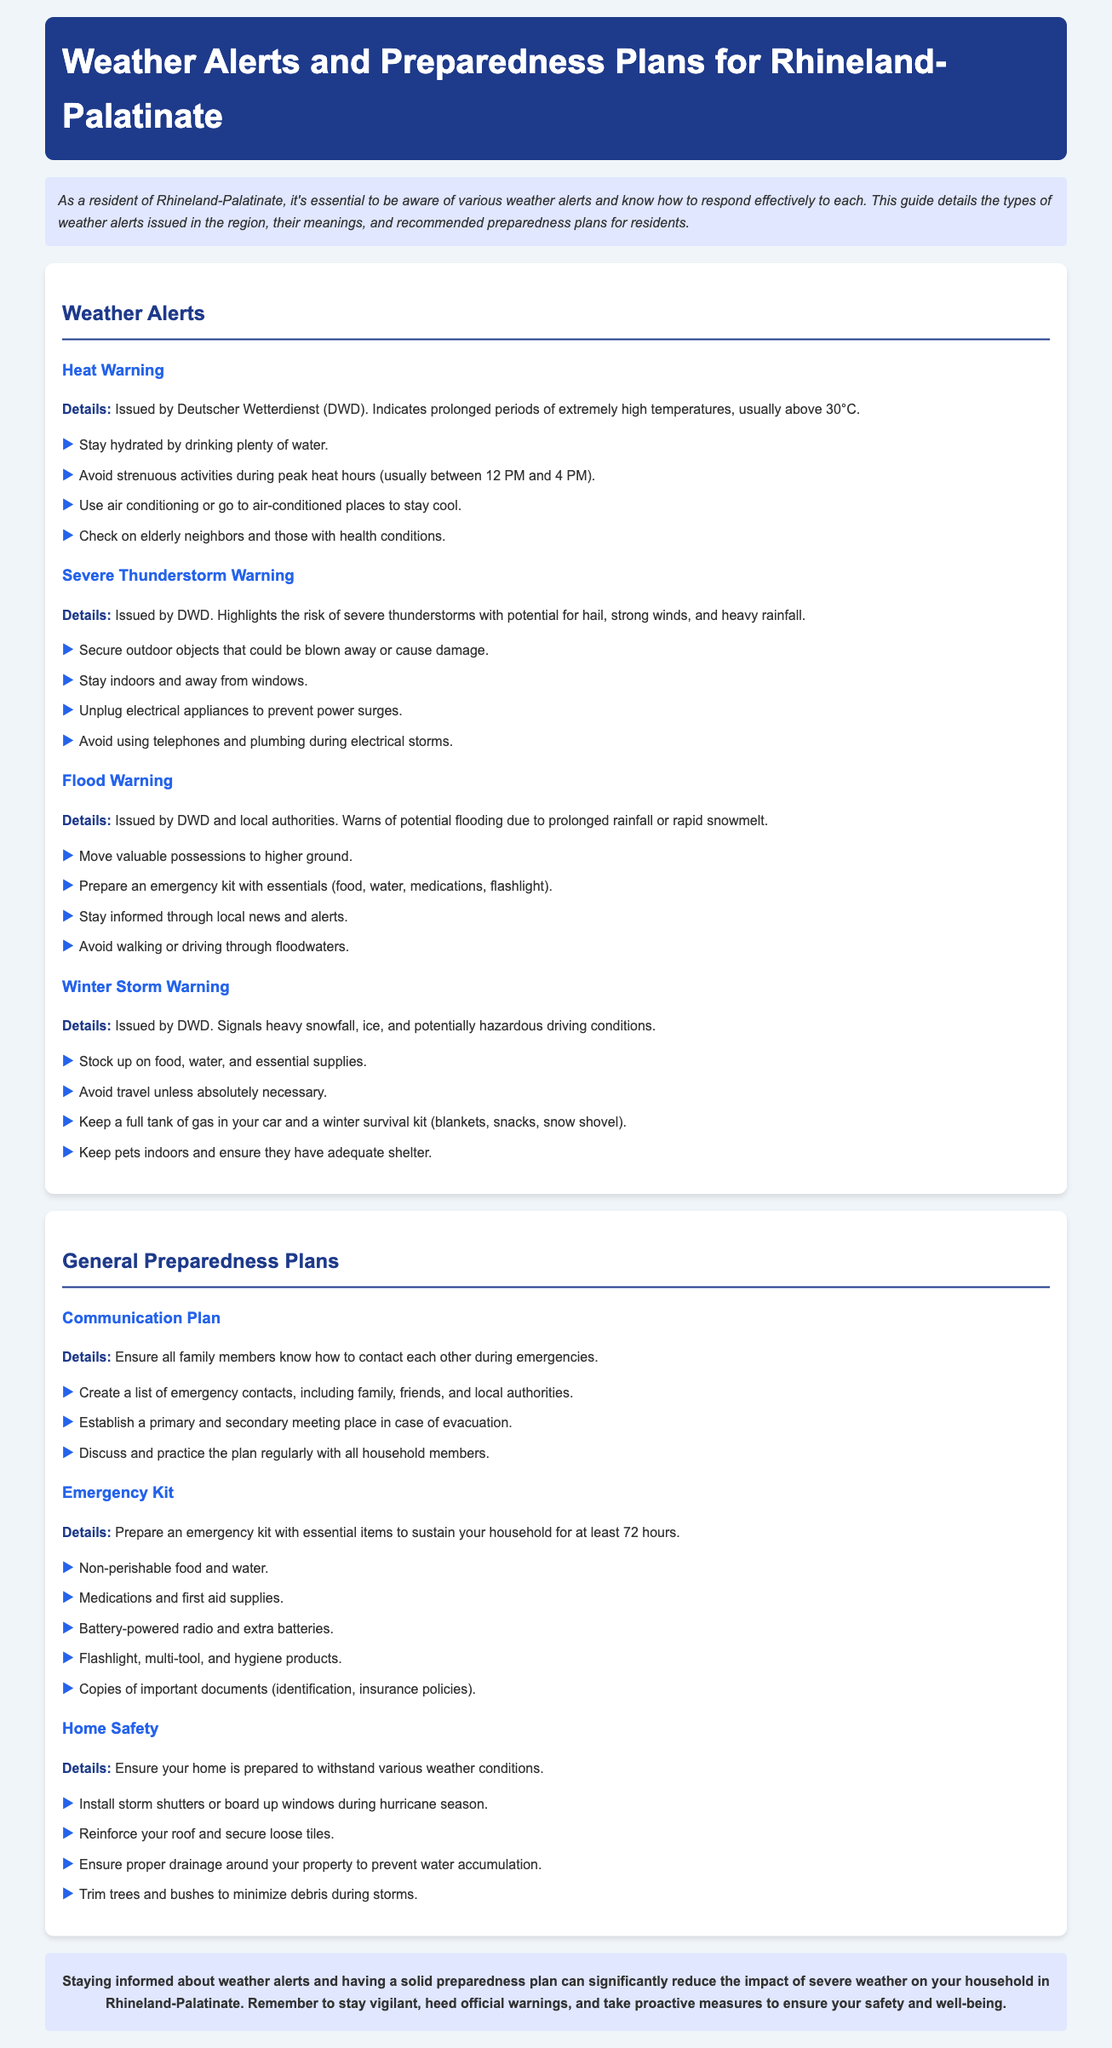What is a heat warning? A heat warning indicates prolonged periods of extremely high temperatures, usually above 30°C.
Answer: Prolonged periods of extremely high temperatures, usually above 30°C What should you do during a severe thunderstorm warning? During a severe thunderstorm warning, you should stay indoors and away from windows.
Answer: Stay indoors and away from windows What items should be in an emergency kit? An emergency kit should include non-perishable food, water, medications, and first aid supplies.
Answer: Non-perishable food and water What is the recommended action during a flood warning? During a flood warning, you should move valuable possessions to higher ground.
Answer: Move valuable possessions to higher ground What does a winter storm warning signify? A winter storm warning signifies heavy snowfall, ice, and potentially hazardous driving conditions.
Answer: Heavy snowfall, ice, and potentially hazardous driving conditions How long should an emergency kit sustain your household? An emergency kit should sustain your household for at least 72 hours.
Answer: At least 72 hours What should you ensure for home safety? For home safety, ensure proper drainage around your property to prevent water accumulation.
Answer: Proper drainage around your property How often should the communication plan be practiced? The communication plan should be discussed and practiced regularly with all household members.
Answer: Regularly 